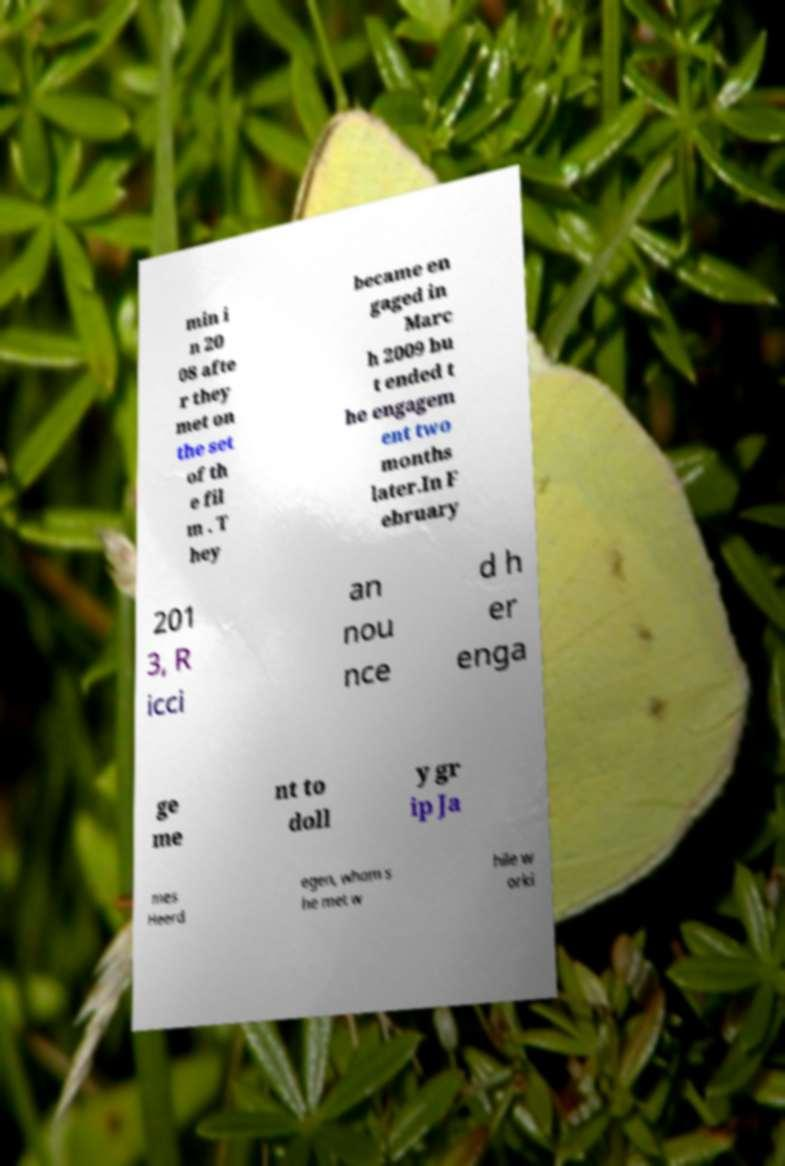Can you read and provide the text displayed in the image?This photo seems to have some interesting text. Can you extract and type it out for me? min i n 20 08 afte r they met on the set of th e fil m . T hey became en gaged in Marc h 2009 bu t ended t he engagem ent two months later.In F ebruary 201 3, R icci an nou nce d h er enga ge me nt to doll y gr ip Ja mes Heerd egen, whom s he met w hile w orki 